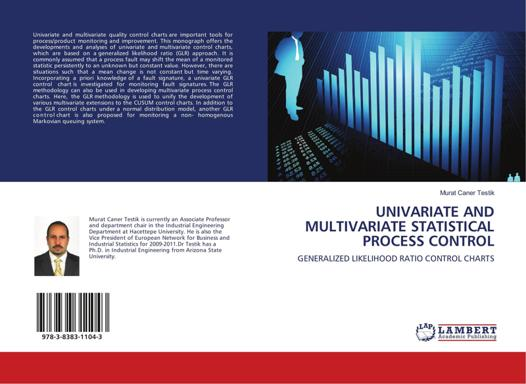How does the cover design relate to the book's content? The cover design, featuring an abstract illustration of statistical bar charts and digital elements, visually represents the book's core focus on data analysis and statistical control in a technological context. This imagery reflects the modern, data-driven approaches the book discusses for monitoring and improving statistical processes, underscoring the synergy between theoretical statistical methods and their practical applications in a high-tech world. 